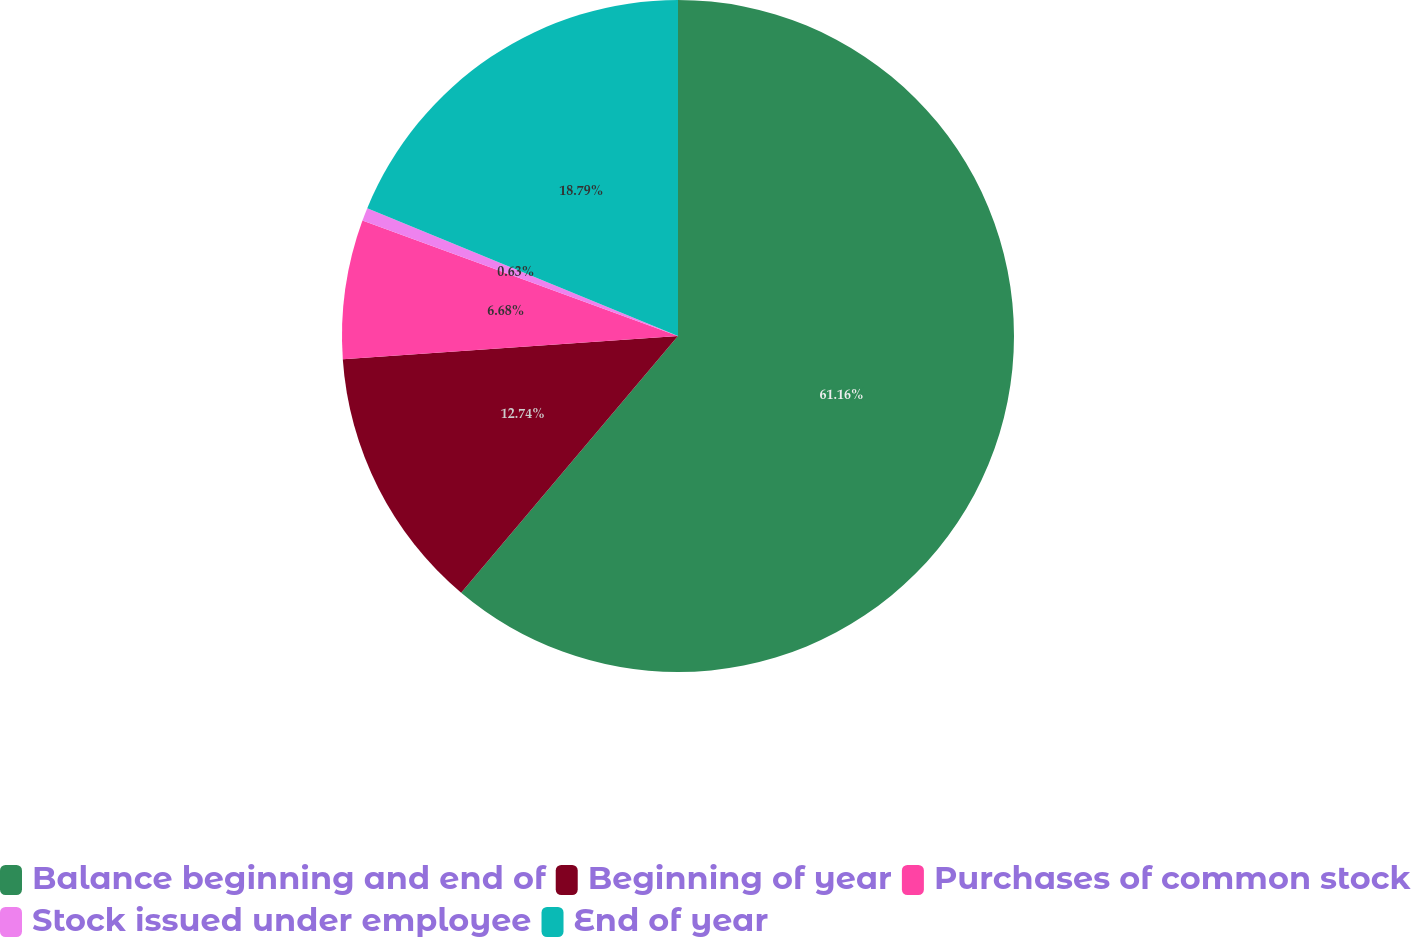Convert chart to OTSL. <chart><loc_0><loc_0><loc_500><loc_500><pie_chart><fcel>Balance beginning and end of<fcel>Beginning of year<fcel>Purchases of common stock<fcel>Stock issued under employee<fcel>End of year<nl><fcel>61.17%<fcel>12.74%<fcel>6.68%<fcel>0.63%<fcel>18.79%<nl></chart> 